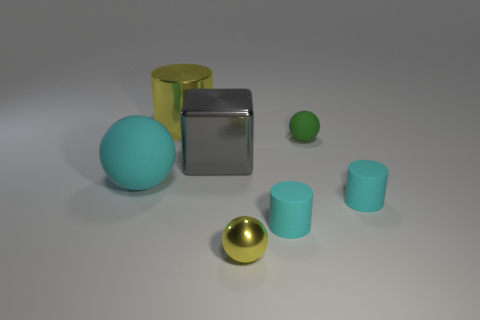Add 2 tiny rubber things. How many objects exist? 9 Subtract all cylinders. How many objects are left? 4 Add 2 tiny green balls. How many tiny green balls exist? 3 Subtract 1 cyan balls. How many objects are left? 6 Subtract all gray things. Subtract all matte cylinders. How many objects are left? 4 Add 5 big gray cubes. How many big gray cubes are left? 6 